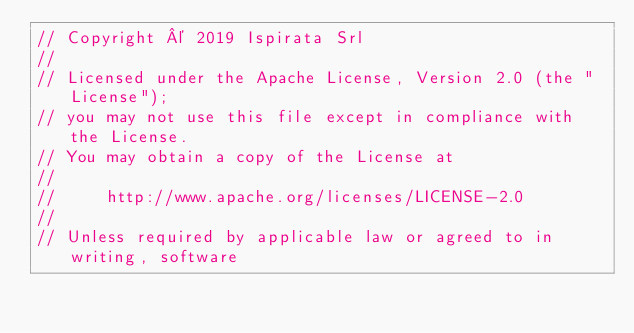<code> <loc_0><loc_0><loc_500><loc_500><_Go_>// Copyright © 2019 Ispirata Srl
//
// Licensed under the Apache License, Version 2.0 (the "License");
// you may not use this file except in compliance with the License.
// You may obtain a copy of the License at
//
//     http://www.apache.org/licenses/LICENSE-2.0
//
// Unless required by applicable law or agreed to in writing, software</code> 